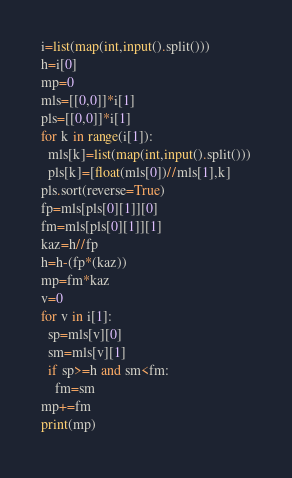<code> <loc_0><loc_0><loc_500><loc_500><_Python_>i=list(map(int,input().split()))
h=i[0]
mp=0
mls=[[0,0]]*i[1]
pls=[[0,0]]*i[1]
for k in range(i[1]):
  mls[k]=list(map(int,input().split()))
  pls[k]=[float(mls[0])//mls[1],k]
pls.sort(reverse=True)
fp=mls[pls[0][1]][0]
fm=mls[pls[0][1]][1]
kaz=h//fp
h=h-(fp*(kaz))
mp=fm*kaz
v=0
for v in i[1]:
  sp=mls[v][0]
  sm=mls[v][1]
  if sp>=h and sm<fm:
    fm=sm
mp+=fm
print(mp)
</code> 